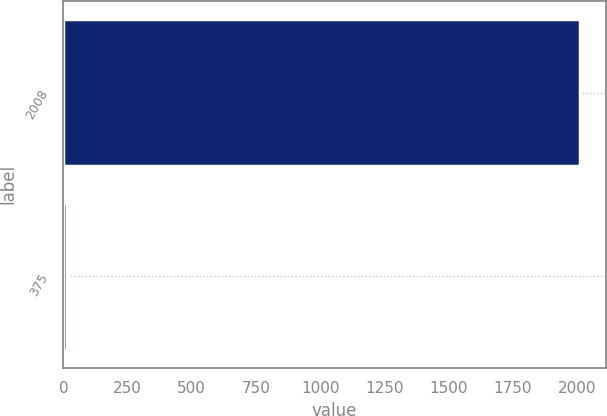Convert chart to OTSL. <chart><loc_0><loc_0><loc_500><loc_500><bar_chart><fcel>2008<fcel>375<nl><fcel>2012<fcel>15.9<nl></chart> 